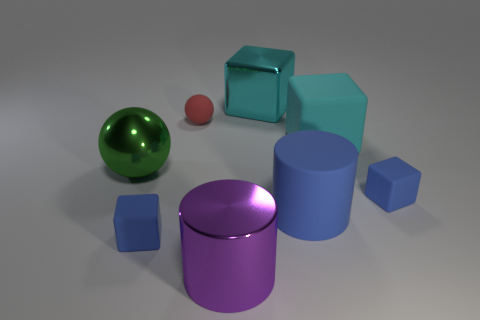What number of things are rubber objects that are behind the large green metallic sphere or large metallic objects?
Make the answer very short. 5. Do the big metallic cube and the small matte block that is to the left of the cyan metallic object have the same color?
Your answer should be compact. No. Are there any blue matte things that have the same size as the rubber sphere?
Offer a terse response. Yes. What material is the blue block that is to the left of the purple thing in front of the big blue matte cylinder made of?
Provide a succinct answer. Rubber. How many spheres have the same color as the large shiny block?
Your response must be concise. 0. What is the shape of the cyan object that is made of the same material as the small red ball?
Your response must be concise. Cube. There is a matte cylinder that is in front of the red matte ball; what is its size?
Provide a short and direct response. Large. Are there the same number of blue rubber blocks in front of the big cyan metallic thing and large blue matte cylinders behind the green metal sphere?
Provide a short and direct response. No. What color is the sphere left of the blue matte block that is left of the metallic object behind the big green ball?
Your answer should be compact. Green. What number of rubber objects are right of the big cyan shiny block and in front of the big ball?
Provide a short and direct response. 2. 